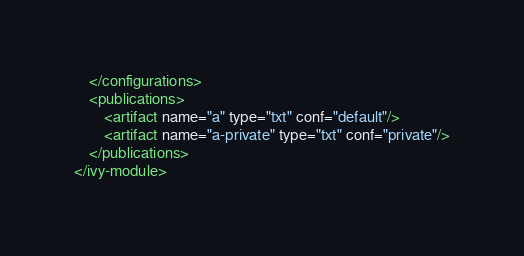<code> <loc_0><loc_0><loc_500><loc_500><_XML_>    </configurations>    
    <publications>
		<artifact name="a" type="txt" conf="default"/>
		<artifact name="a-private" type="txt" conf="private"/>
    </publications>
</ivy-module></code> 